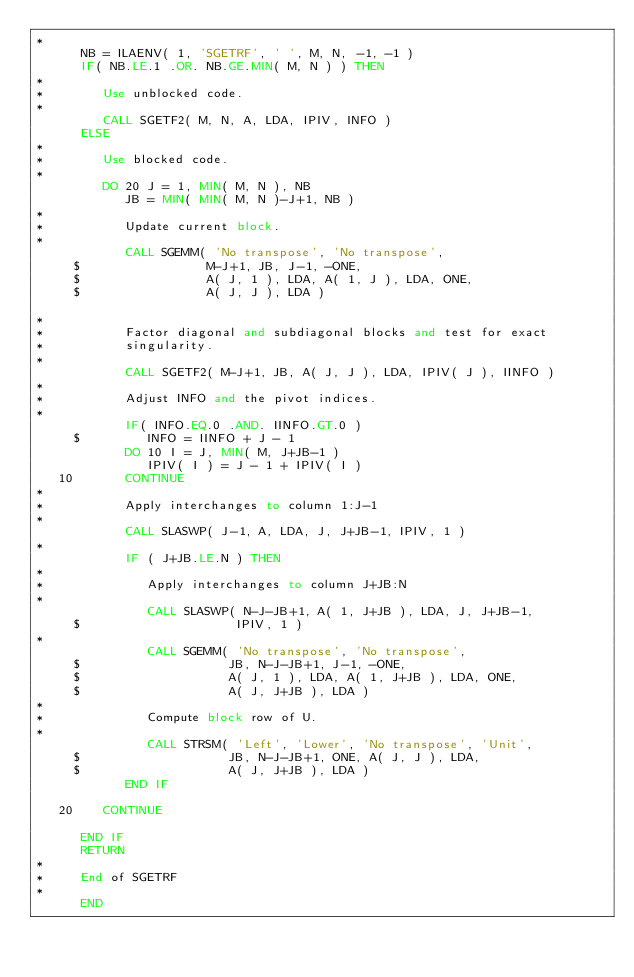Convert code to text. <code><loc_0><loc_0><loc_500><loc_500><_FORTRAN_>*
      NB = ILAENV( 1, 'SGETRF', ' ', M, N, -1, -1 )
      IF( NB.LE.1 .OR. NB.GE.MIN( M, N ) ) THEN
*
*        Use unblocked code.
*
         CALL SGETF2( M, N, A, LDA, IPIV, INFO )
      ELSE
*
*        Use blocked code.
*
         DO 20 J = 1, MIN( M, N ), NB
            JB = MIN( MIN( M, N )-J+1, NB )
*
*           Update current block.
*
            CALL SGEMM( 'No transpose', 'No transpose', 
     $                 M-J+1, JB, J-1, -ONE, 
     $                 A( J, 1 ), LDA, A( 1, J ), LDA, ONE,
     $                 A( J, J ), LDA )
            
*
*           Factor diagonal and subdiagonal blocks and test for exact
*           singularity.
*
            CALL SGETF2( M-J+1, JB, A( J, J ), LDA, IPIV( J ), IINFO )
*
*           Adjust INFO and the pivot indices.
*
            IF( INFO.EQ.0 .AND. IINFO.GT.0 )
     $         INFO = IINFO + J - 1
            DO 10 I = J, MIN( M, J+JB-1 )
               IPIV( I ) = J - 1 + IPIV( I )
   10       CONTINUE
*            
*           Apply interchanges to column 1:J-1            
*
            CALL SLASWP( J-1, A, LDA, J, J+JB-1, IPIV, 1 )
*
            IF ( J+JB.LE.N ) THEN
*            
*              Apply interchanges to column J+JB:N            
*
               CALL SLASWP( N-J-JB+1, A( 1, J+JB ), LDA, J, J+JB-1, 
     $                     IPIV, 1 )
*               
               CALL SGEMM( 'No transpose', 'No transpose', 
     $                    JB, N-J-JB+1, J-1, -ONE, 
     $                    A( J, 1 ), LDA, A( 1, J+JB ), LDA, ONE,
     $                    A( J, J+JB ), LDA )
*
*              Compute block row of U.
*
               CALL STRSM( 'Left', 'Lower', 'No transpose', 'Unit',
     $                    JB, N-J-JB+1, ONE, A( J, J ), LDA, 
     $                    A( J, J+JB ), LDA )
            END IF

   20    CONTINUE

      END IF
      RETURN
*
*     End of SGETRF
*
      END
</code> 